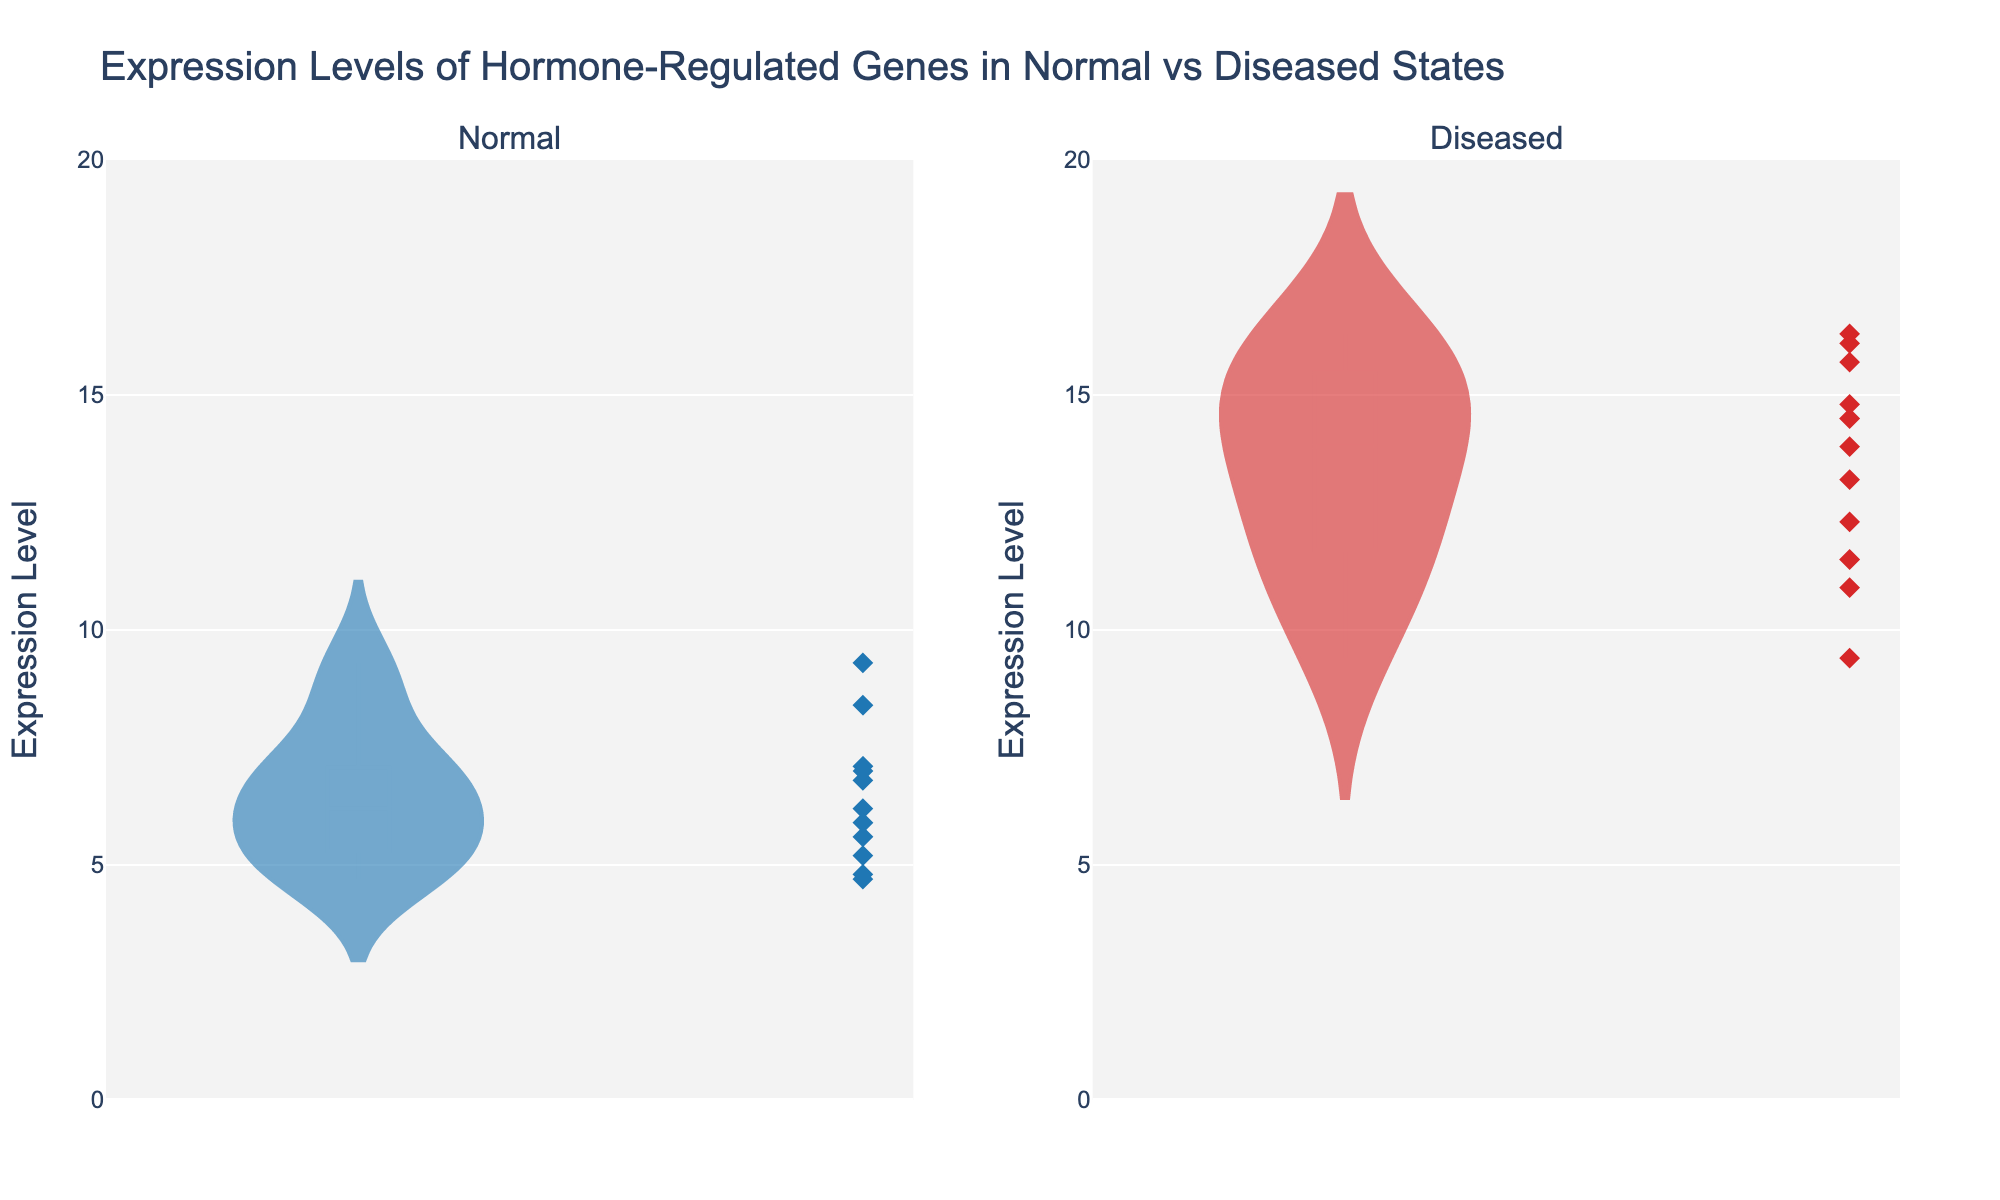What's the title of the figure? The title of the figure is typically found at the top, providing an overview of what the figure represents. Here, it shows "Expression Levels of Hormone-Regulated Genes in Normal vs Diseased States".
Answer: Expression Levels of Hormone-Regulated Genes in Normal vs Diseased States What is the range of the expression levels displayed on the y-axis? The y-axis range indicates the minimum and maximum values of the expression levels. By examining both subplots, we see it ranges from 0 to 20.
Answer: 0 to 20 How many genes are represented for the normal condition? Each dot and trace in the first subplot of the violin plot corresponds to a gene. By counting these, we see there are 11 genes represented for the normal condition.
Answer: 11 Which condition has higher median expression levels based on the figure? Each violin plot shows a distribution's median as a line within the plot. By comparing the median lines in both subplots, we see that the diseased condition has higher median expression levels.
Answer: Diseased What is the expression level of HSD11B1 in normal and diseased states? To find the expression levels of a specific gene, we look at the specific data points or marks in both subplots. HSD11B1 is at 8.4 in the normal state and 15.7 in the diseased state.
Answer: Normal: 8.4, Diseased: 15.7 What is the average expression level in the diseased state? First, sum all the expression levels for the diseased state (15.7 + 13.9 + 9.4 + 12.3 + 14.8 + 16.1 + 11.5 + 13.2 + 14.5 + 16.3 + 10.9 = 148.6), then divide by the number of genes (11): 148.6 / 11 = 13.5.
Answer: 13.5 Which gene shows the most significant change in expression between normal and diseased states? Calculate the differences in expression levels for each gene between normal and diseased states. The most significant change is seen in BRAF, with a change of 16.3 - 7.0 = 9.3.
Answer: BRAF Do any genes have the same expression levels in both normal and diseased states? By checking each gene's expression levels, we see no genes have the same value in both states.
Answer: No Which data point in the diseased state is the highest, and which gene does it represent? To determine the highest data point, look at the diseased subplot and find the highest peak, which is at 16.3, representing BRAF.
Answer: 16.3, BRAF 